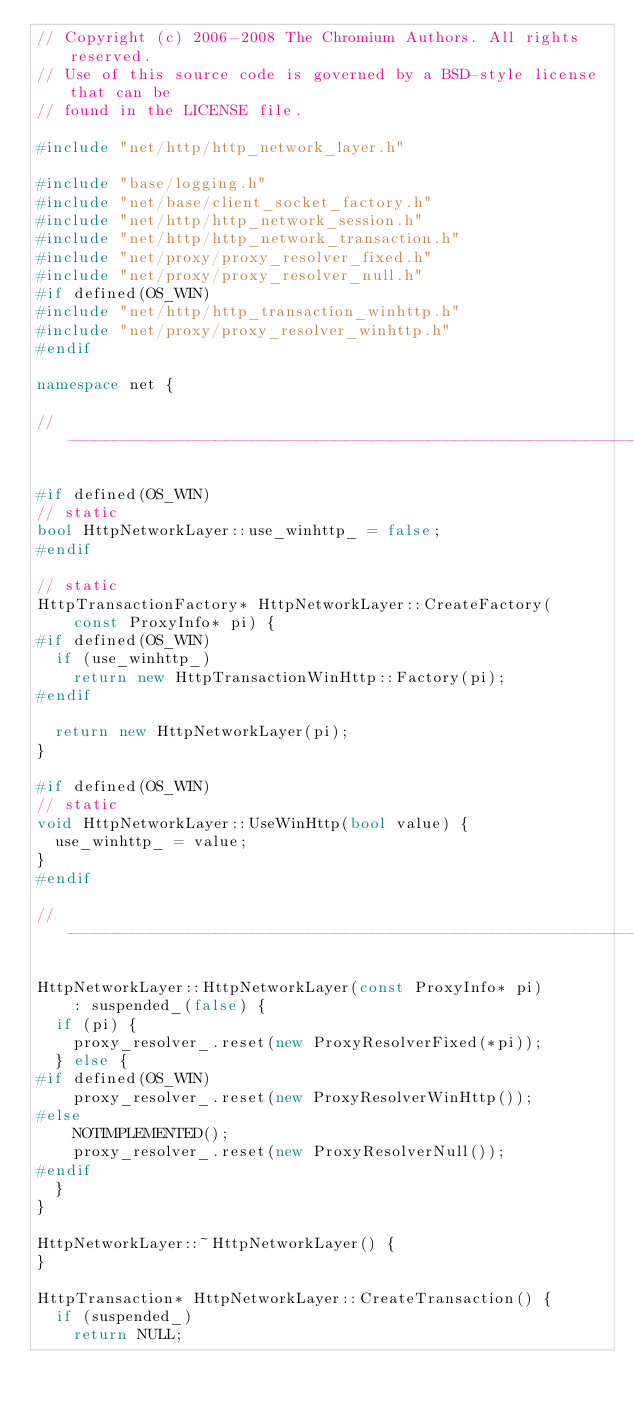Convert code to text. <code><loc_0><loc_0><loc_500><loc_500><_C++_>// Copyright (c) 2006-2008 The Chromium Authors. All rights reserved.
// Use of this source code is governed by a BSD-style license that can be
// found in the LICENSE file.

#include "net/http/http_network_layer.h"

#include "base/logging.h"
#include "net/base/client_socket_factory.h"
#include "net/http/http_network_session.h"
#include "net/http/http_network_transaction.h"
#include "net/proxy/proxy_resolver_fixed.h"
#include "net/proxy/proxy_resolver_null.h"
#if defined(OS_WIN)
#include "net/http/http_transaction_winhttp.h"
#include "net/proxy/proxy_resolver_winhttp.h"
#endif

namespace net {

//-----------------------------------------------------------------------------

#if defined(OS_WIN)
// static
bool HttpNetworkLayer::use_winhttp_ = false;
#endif

// static
HttpTransactionFactory* HttpNetworkLayer::CreateFactory(
    const ProxyInfo* pi) {
#if defined(OS_WIN)
  if (use_winhttp_)
    return new HttpTransactionWinHttp::Factory(pi);
#endif

  return new HttpNetworkLayer(pi);
}

#if defined(OS_WIN)
// static
void HttpNetworkLayer::UseWinHttp(bool value) {
  use_winhttp_ = value;
}
#endif

//-----------------------------------------------------------------------------

HttpNetworkLayer::HttpNetworkLayer(const ProxyInfo* pi)
    : suspended_(false) {
  if (pi) {
    proxy_resolver_.reset(new ProxyResolverFixed(*pi));
  } else {
#if defined(OS_WIN)
    proxy_resolver_.reset(new ProxyResolverWinHttp());
#else
    NOTIMPLEMENTED();
    proxy_resolver_.reset(new ProxyResolverNull());
#endif
  }
}

HttpNetworkLayer::~HttpNetworkLayer() {
}

HttpTransaction* HttpNetworkLayer::CreateTransaction() {
  if (suspended_)
    return NULL;
</code> 